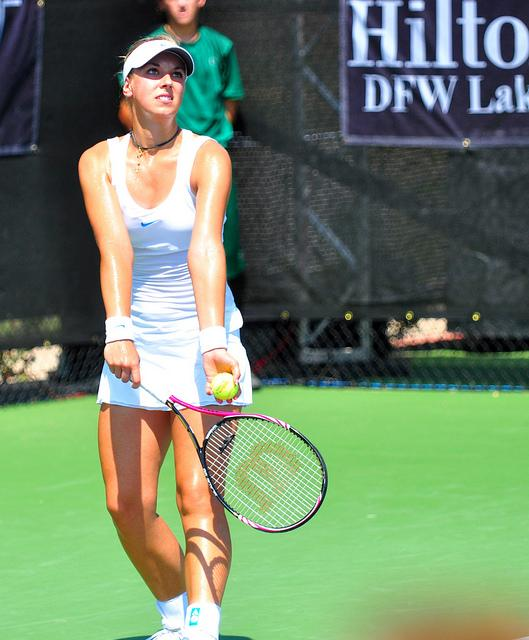Why is she holding the ball? serving 